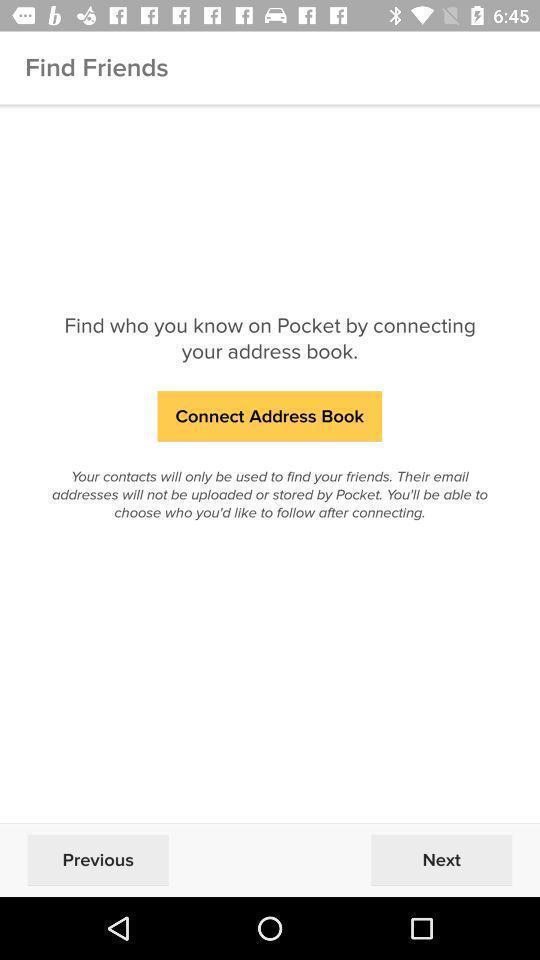Provide a description of this screenshot. Welcome page of a social app with connect option. 